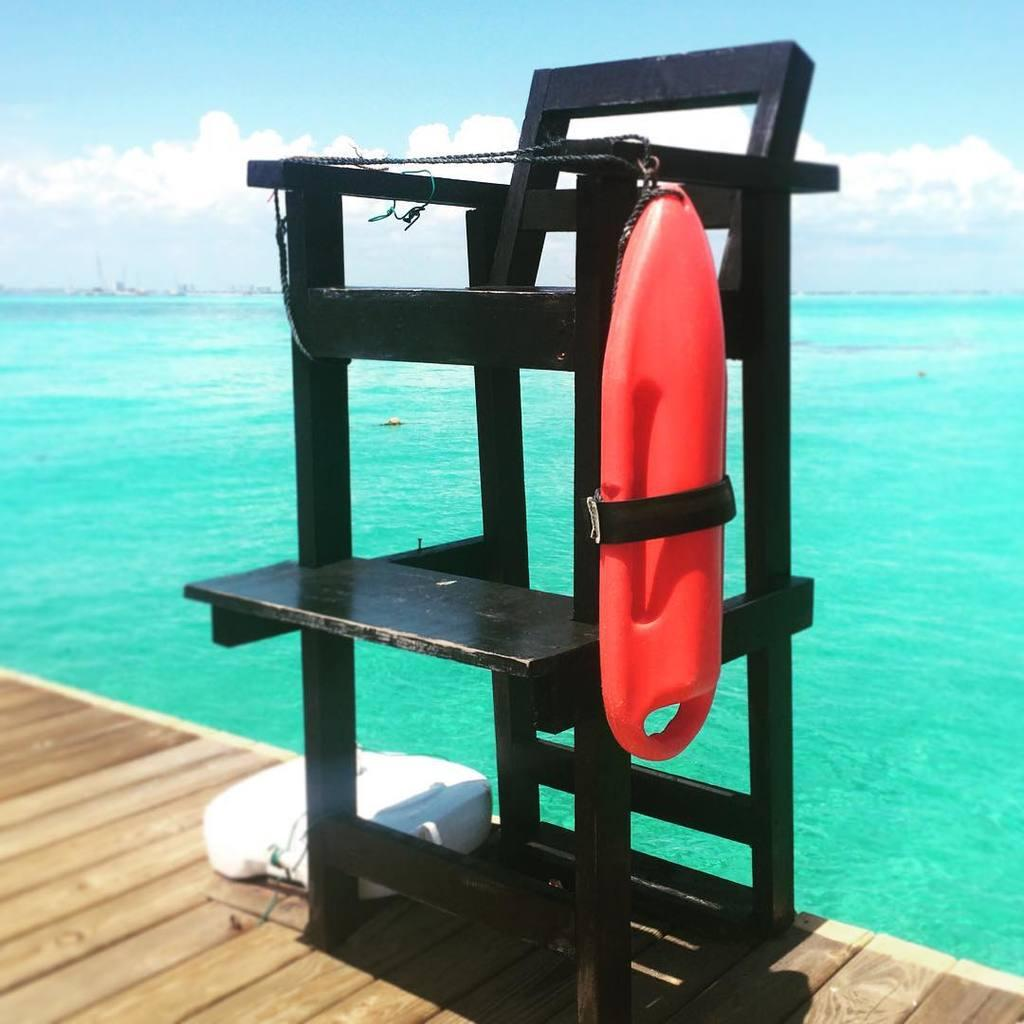What is visible in the image that is not a solid surface? Water is visible in the image. What type of surface can be seen in the image? There is a wooden surface in the image. What is visible at the top of the image? The sky is visible at the top of the image. What type of furniture is present in the image? There is a chair in the image. What type of silk is draped over the chair in the image? There is no silk present in the image; it only features water, a wooden surface, the sky, and a chair. What type of hat is the person wearing in the image? There is no person or hat present in the image. 